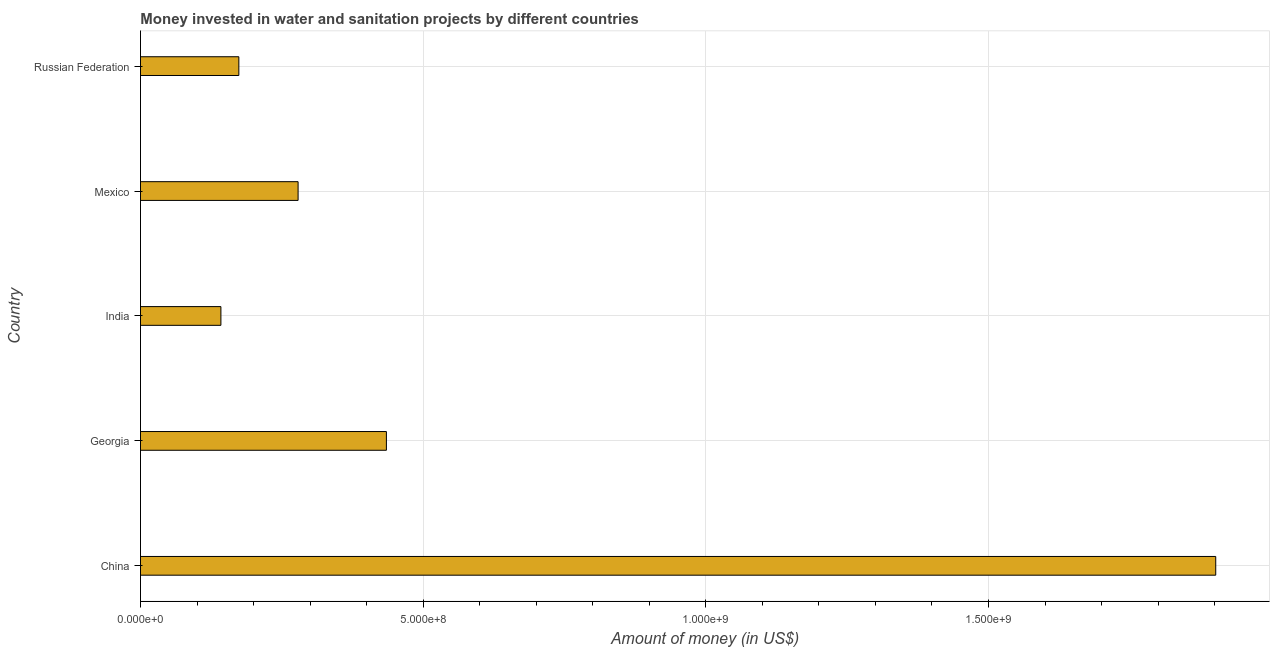Does the graph contain any zero values?
Your response must be concise. No. Does the graph contain grids?
Keep it short and to the point. Yes. What is the title of the graph?
Offer a terse response. Money invested in water and sanitation projects by different countries. What is the label or title of the X-axis?
Your response must be concise. Amount of money (in US$). What is the label or title of the Y-axis?
Provide a short and direct response. Country. What is the investment in Georgia?
Ensure brevity in your answer.  4.35e+08. Across all countries, what is the maximum investment?
Give a very brief answer. 1.90e+09. Across all countries, what is the minimum investment?
Offer a terse response. 1.42e+08. What is the sum of the investment?
Provide a succinct answer. 2.93e+09. What is the difference between the investment in China and India?
Make the answer very short. 1.76e+09. What is the average investment per country?
Make the answer very short. 5.86e+08. What is the median investment?
Your response must be concise. 2.79e+08. What is the ratio of the investment in Mexico to that in Russian Federation?
Make the answer very short. 1.6. Is the investment in China less than that in India?
Offer a terse response. No. Is the difference between the investment in China and Georgia greater than the difference between any two countries?
Your answer should be very brief. No. What is the difference between the highest and the second highest investment?
Your answer should be compact. 1.47e+09. Is the sum of the investment in Georgia and Mexico greater than the maximum investment across all countries?
Ensure brevity in your answer.  No. What is the difference between the highest and the lowest investment?
Offer a very short reply. 1.76e+09. What is the Amount of money (in US$) of China?
Provide a short and direct response. 1.90e+09. What is the Amount of money (in US$) in Georgia?
Make the answer very short. 4.35e+08. What is the Amount of money (in US$) in India?
Provide a short and direct response. 1.42e+08. What is the Amount of money (in US$) in Mexico?
Your response must be concise. 2.79e+08. What is the Amount of money (in US$) in Russian Federation?
Keep it short and to the point. 1.74e+08. What is the difference between the Amount of money (in US$) in China and Georgia?
Your answer should be compact. 1.47e+09. What is the difference between the Amount of money (in US$) in China and India?
Provide a short and direct response. 1.76e+09. What is the difference between the Amount of money (in US$) in China and Mexico?
Give a very brief answer. 1.62e+09. What is the difference between the Amount of money (in US$) in China and Russian Federation?
Give a very brief answer. 1.73e+09. What is the difference between the Amount of money (in US$) in Georgia and India?
Provide a succinct answer. 2.93e+08. What is the difference between the Amount of money (in US$) in Georgia and Mexico?
Your answer should be compact. 1.56e+08. What is the difference between the Amount of money (in US$) in Georgia and Russian Federation?
Provide a short and direct response. 2.61e+08. What is the difference between the Amount of money (in US$) in India and Mexico?
Your response must be concise. -1.37e+08. What is the difference between the Amount of money (in US$) in India and Russian Federation?
Keep it short and to the point. -3.18e+07. What is the difference between the Amount of money (in US$) in Mexico and Russian Federation?
Give a very brief answer. 1.05e+08. What is the ratio of the Amount of money (in US$) in China to that in Georgia?
Keep it short and to the point. 4.37. What is the ratio of the Amount of money (in US$) in China to that in India?
Your answer should be very brief. 13.37. What is the ratio of the Amount of money (in US$) in China to that in Mexico?
Ensure brevity in your answer.  6.82. What is the ratio of the Amount of money (in US$) in China to that in Russian Federation?
Provide a short and direct response. 10.93. What is the ratio of the Amount of money (in US$) in Georgia to that in India?
Keep it short and to the point. 3.06. What is the ratio of the Amount of money (in US$) in Georgia to that in Mexico?
Give a very brief answer. 1.56. What is the ratio of the Amount of money (in US$) in India to that in Mexico?
Make the answer very short. 0.51. What is the ratio of the Amount of money (in US$) in India to that in Russian Federation?
Keep it short and to the point. 0.82. What is the ratio of the Amount of money (in US$) in Mexico to that in Russian Federation?
Keep it short and to the point. 1.6. 